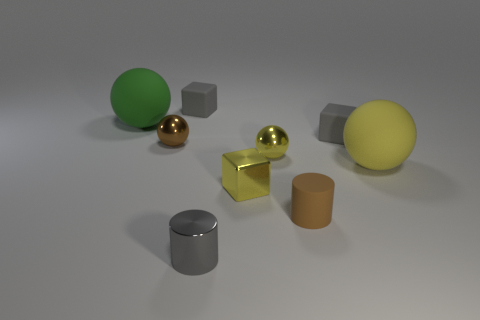What number of gray cubes have the same size as the rubber cylinder?
Your answer should be compact. 2. How many metallic objects are either green objects or tiny cubes?
Offer a very short reply. 1. The metal object that is the same color as the matte cylinder is what size?
Give a very brief answer. Small. What is the small cube that is in front of the big ball to the right of the big green rubber ball made of?
Offer a very short reply. Metal. What number of objects are either large green matte objects or matte spheres right of the tiny gray shiny object?
Offer a very short reply. 2. What is the size of the yellow sphere that is the same material as the tiny brown cylinder?
Ensure brevity in your answer.  Large. How many yellow things are either tiny shiny cubes or metal spheres?
Your answer should be compact. 2. There is a tiny metal thing that is the same color as the small matte cylinder; what shape is it?
Give a very brief answer. Sphere. Is the shape of the large yellow thing that is right of the tiny yellow ball the same as the yellow metal thing to the right of the tiny yellow block?
Provide a succinct answer. Yes. What number of purple shiny cylinders are there?
Offer a terse response. 0. 